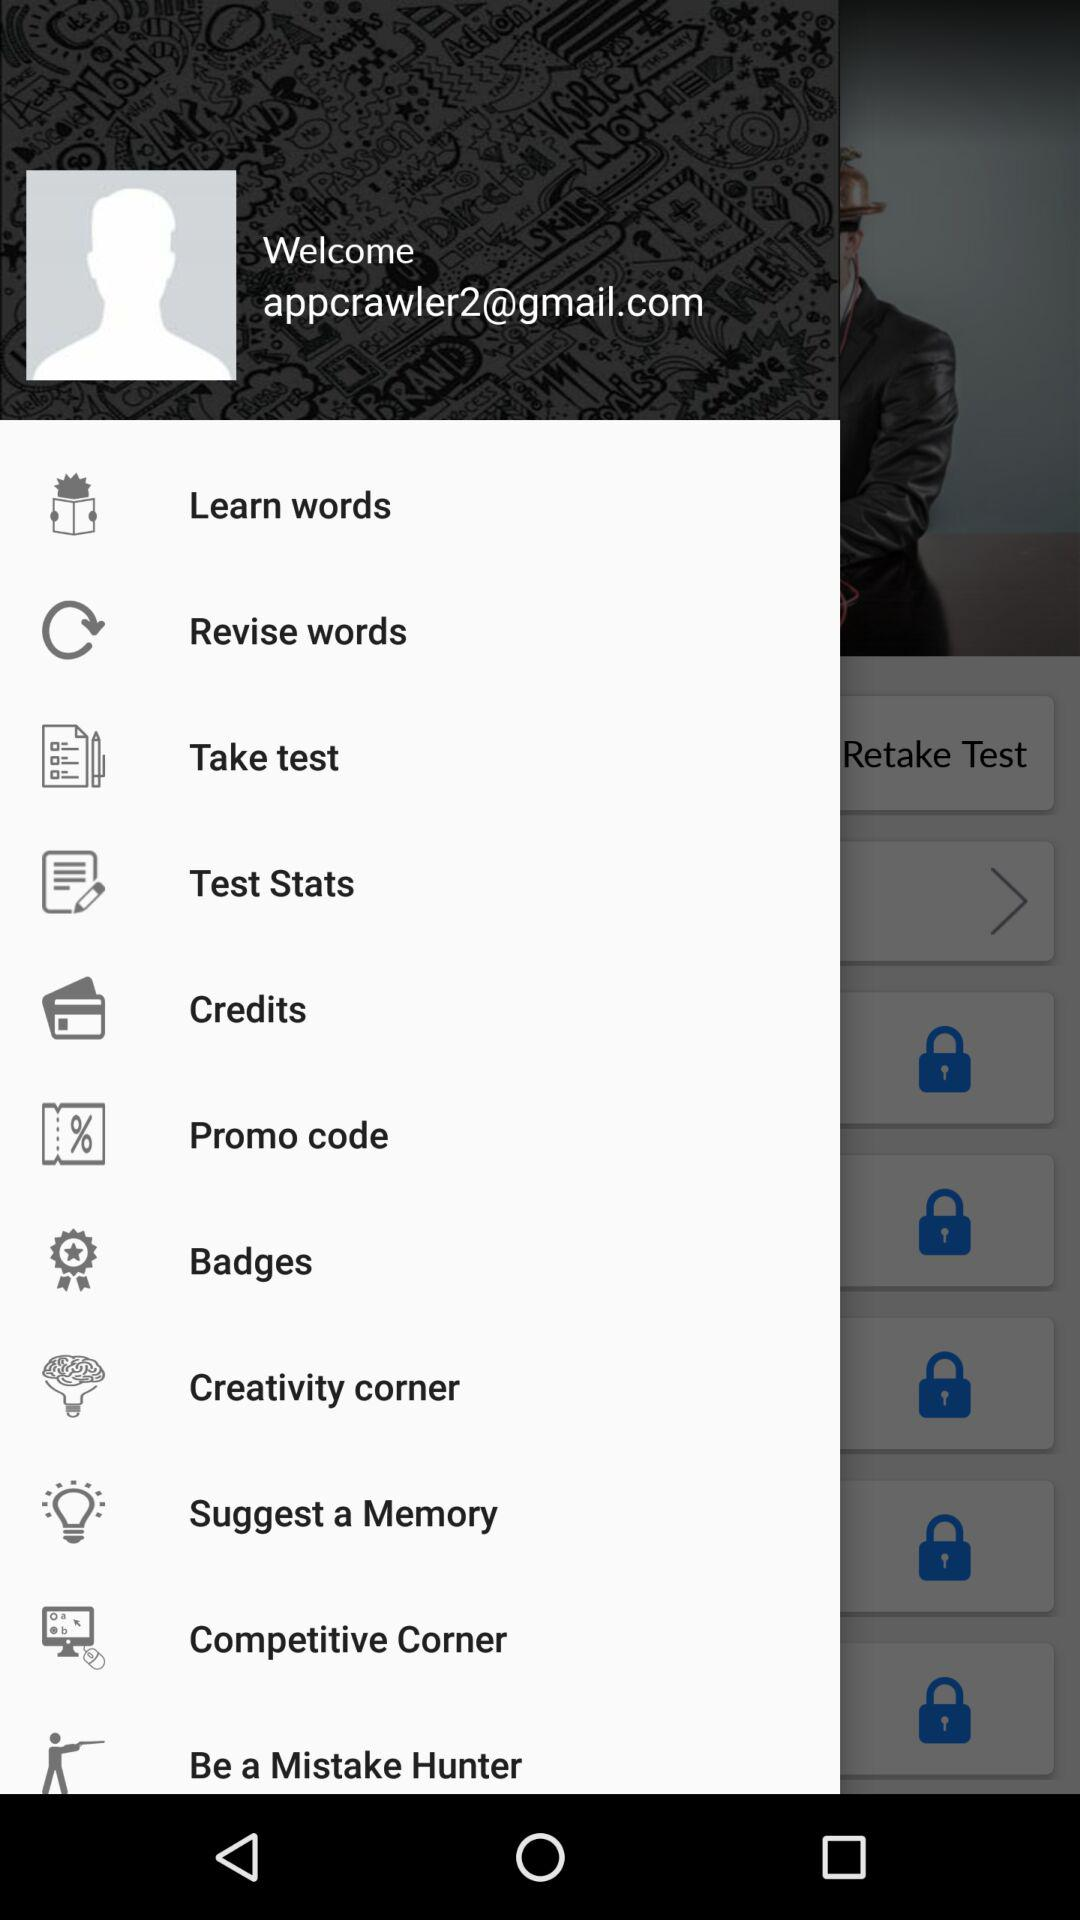What is the given email address? The given email address is appcrawler2@gmail.com. 